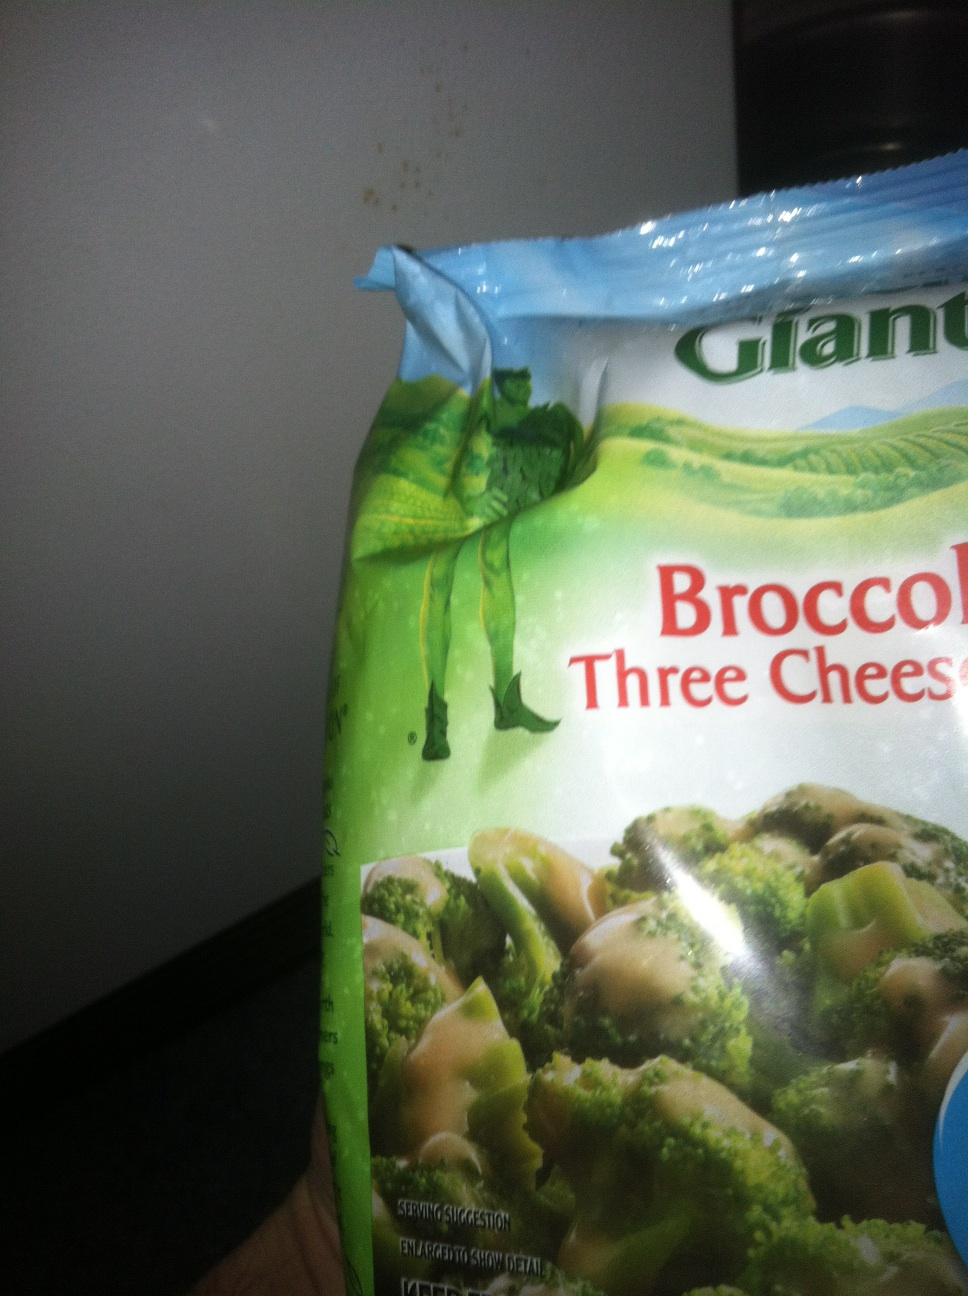Can you create a very detailed description or story connected to this product? Absolutely! Imagine you're hosting a cozy winter dinner party for your friends. The main course is a rich and hearty beef stew that has been simmering on the stove all day. The aroma fills the room with warmth and comfort. For the side dish, you decide to serve something equally comforting and tasty. You reach into your freezer and pull out a bag of Green Giant Broccoli Three Cheese Sauce. As you prepare the broccoli, you think about the rich and creamy cheese sauce that will perfectly complement the stew. The golden cheese sauce melts and spreads over the vibrant green broccoli florets, creating a colorful and mouth-watering dish. When you serve the food, your guests can't help but be impressed by the delicious combination of flavors. The cheesy broccoli pairs wonderfully with the savory beef stew, and everyone leaves the table feeling satisfied and happy. Can you come up with an extremely long and detailed description or story? Certainly! Picture a farm tucked away in the verdant hills, where the iconic Green Giant proudly oversees the fields of crisp, green vegetables. Each morning, the sun rises over the rolling hills, casting a golden hue on the dewy leaves of the broccoli plants. This broccoli, nurtured by the rich, fertile soil and pristine waters of the countryside, is destined for greatness. After months of careful tending, the broccoli plants reach their peak, ready for harvest. The Green Giant and his team carefully pick only the freshest, most vibrant broccoli florets, full of nutrients and flavor.

In a nearby kitchen, the broccoli undergoes a transformation. Fresh cream and a blend of three cheeses—sharp cheddar, creamy mozzarella, and a hint of Parmesan—are prepared. The cheeses are carefully melted together, creating a velvety, decadent sauce. The luscious sauce is then poured over the broccoli, ensuring each floret is generously coated, resulting in a perfect harmony of flavors.

The broccoli and cheese sauce is then meticulously packaged in a high-quality, freezer-safe bag, ready to be delivered to stores across the country. Each package is eyed carefully to ensure pristine quality, with a vibrant, eye-catching design that captures the essence of the Green Giant brand.

At home, families find joy in discovering the Green Giant Broccoli Three Cheese Sauce in their freezer aisles. For Sarah, a busy working mom, it’s a lifesaver. She reviews her pantry to find ingredients for a wholesome, delicious dinner her kids will love. Tonight, she decides on a comforting broccoli cheese pasta.

With a pot on the stove, she cooks pasta while the broccoli cheese sauce heats up in the microwave. The aroma of the melting cheese fills the kitchen, stirring excitement. She mixes the tender broccoli with the steaming pasta, creating a luscious, cheesy masterpiece. As she calls her kids to the dinner table, their eyes light up with anticipation.

Mealtime is filled with laughter and joy as the kids relish every bite. The quality and flavor of the Green Giant product stand out, making dinner a hit. For Sarah, it’s more than a meal; it’s a moment of happiness created effortlessly, thanks to the Green Giant Broccoli Three Cheese Sauce.

From the farm to the table, each step reflects care, quality, and the joy of creating delicious, nutritious meals for families everywhere. 